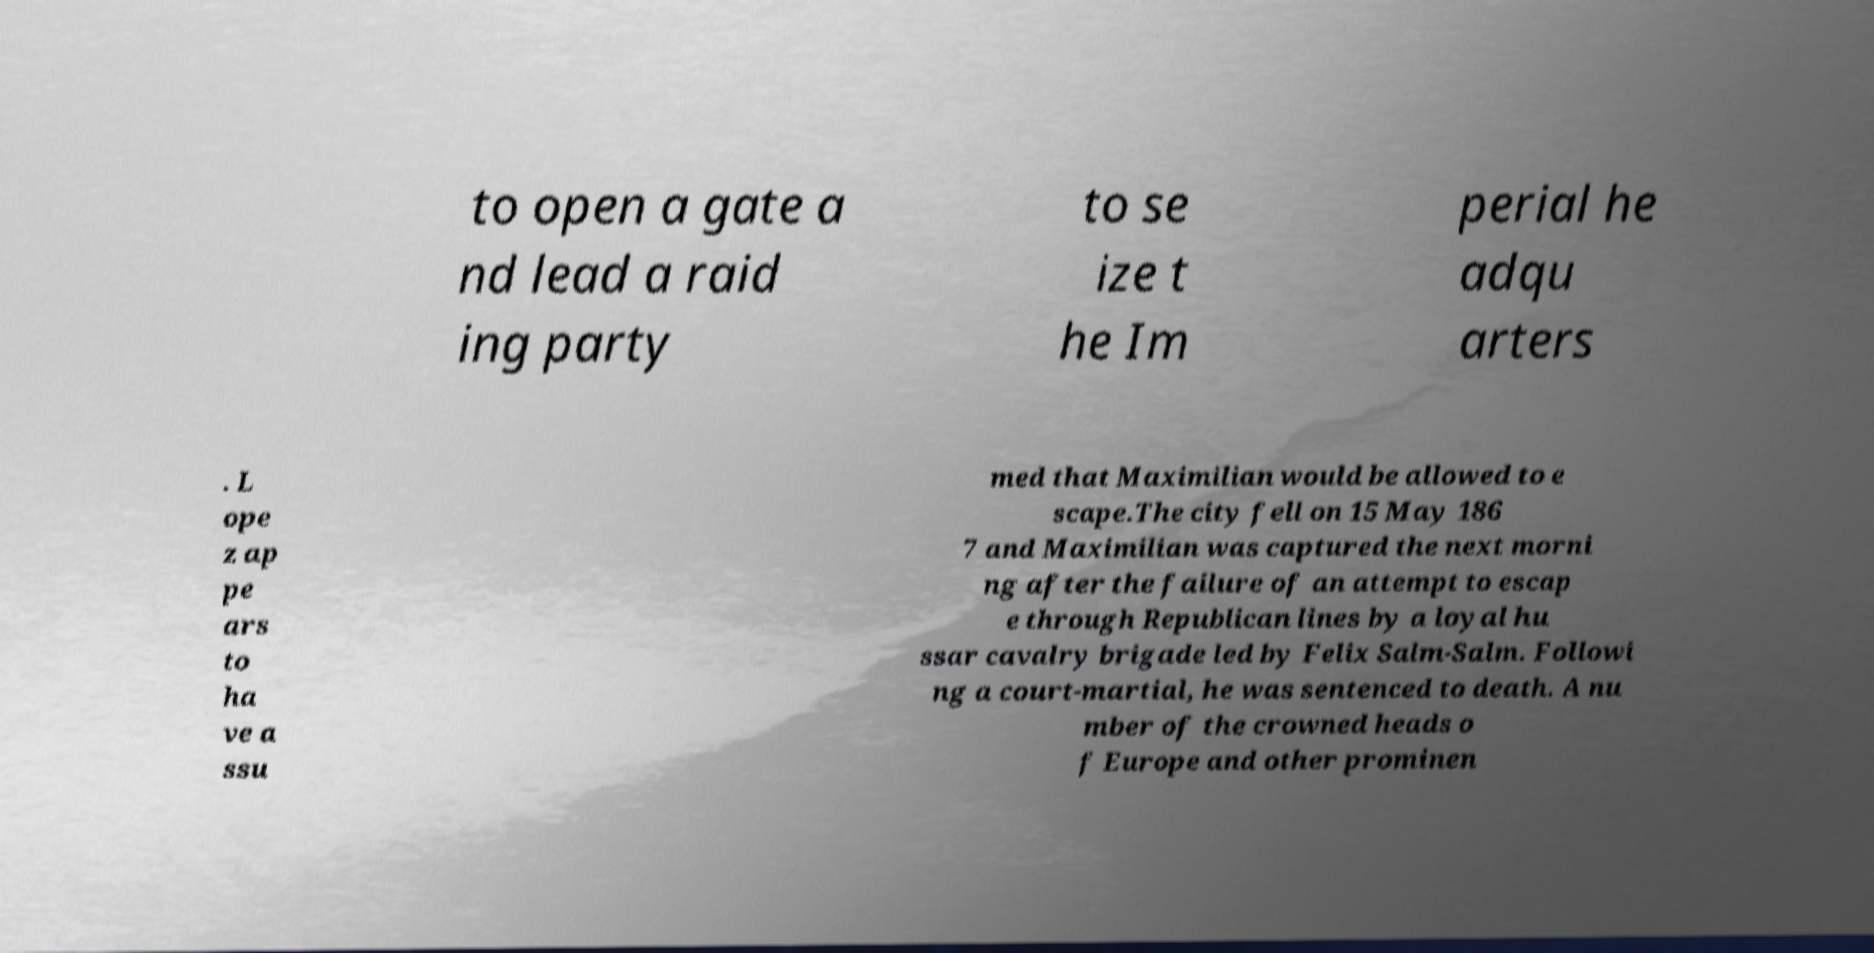There's text embedded in this image that I need extracted. Can you transcribe it verbatim? to open a gate a nd lead a raid ing party to se ize t he Im perial he adqu arters . L ope z ap pe ars to ha ve a ssu med that Maximilian would be allowed to e scape.The city fell on 15 May 186 7 and Maximilian was captured the next morni ng after the failure of an attempt to escap e through Republican lines by a loyal hu ssar cavalry brigade led by Felix Salm-Salm. Followi ng a court-martial, he was sentenced to death. A nu mber of the crowned heads o f Europe and other prominen 